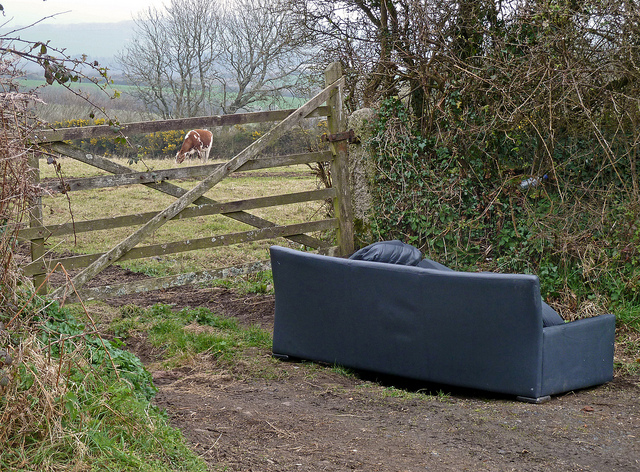<image>Why aren't there any kids playing? It is unknown why there aren't any kids playing. There could be a variety of reasons such as it's school time, or they could be inside. Why aren't there any kids playing? I'm not sure why there aren't any kids playing. It could be because it's school time, there's nothing to play on, or they're inside. 